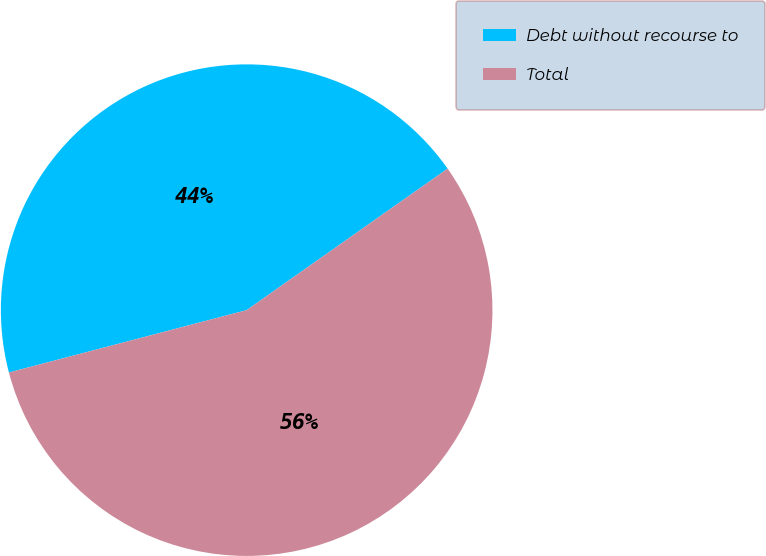Convert chart. <chart><loc_0><loc_0><loc_500><loc_500><pie_chart><fcel>Debt without recourse to<fcel>Total<nl><fcel>44.32%<fcel>55.68%<nl></chart> 